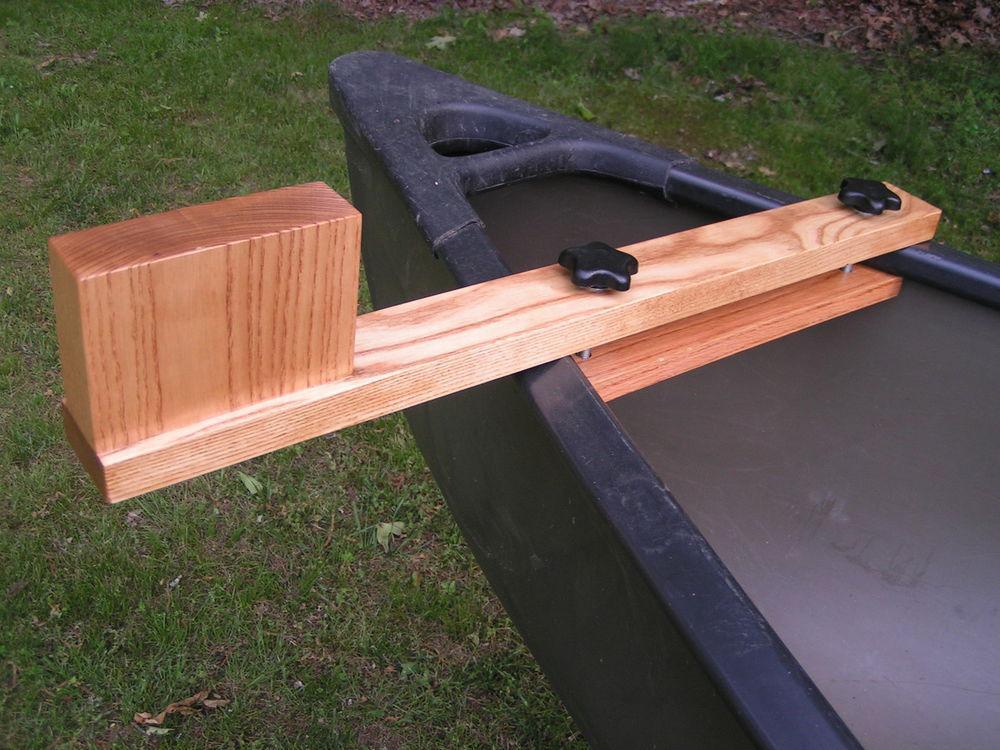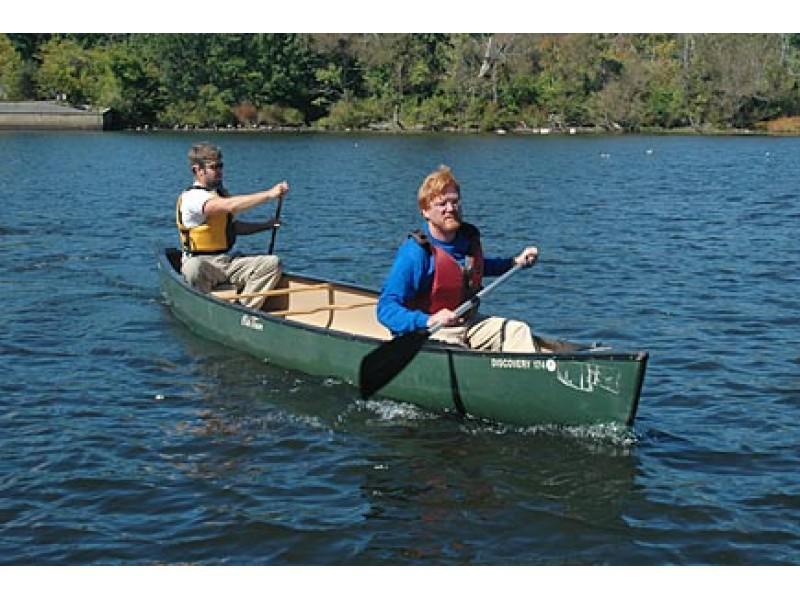The first image is the image on the left, the second image is the image on the right. For the images displayed, is the sentence "An image shows a wooden item attached to an end of a boat, by green ground instead of water." factually correct? Answer yes or no. Yes. 